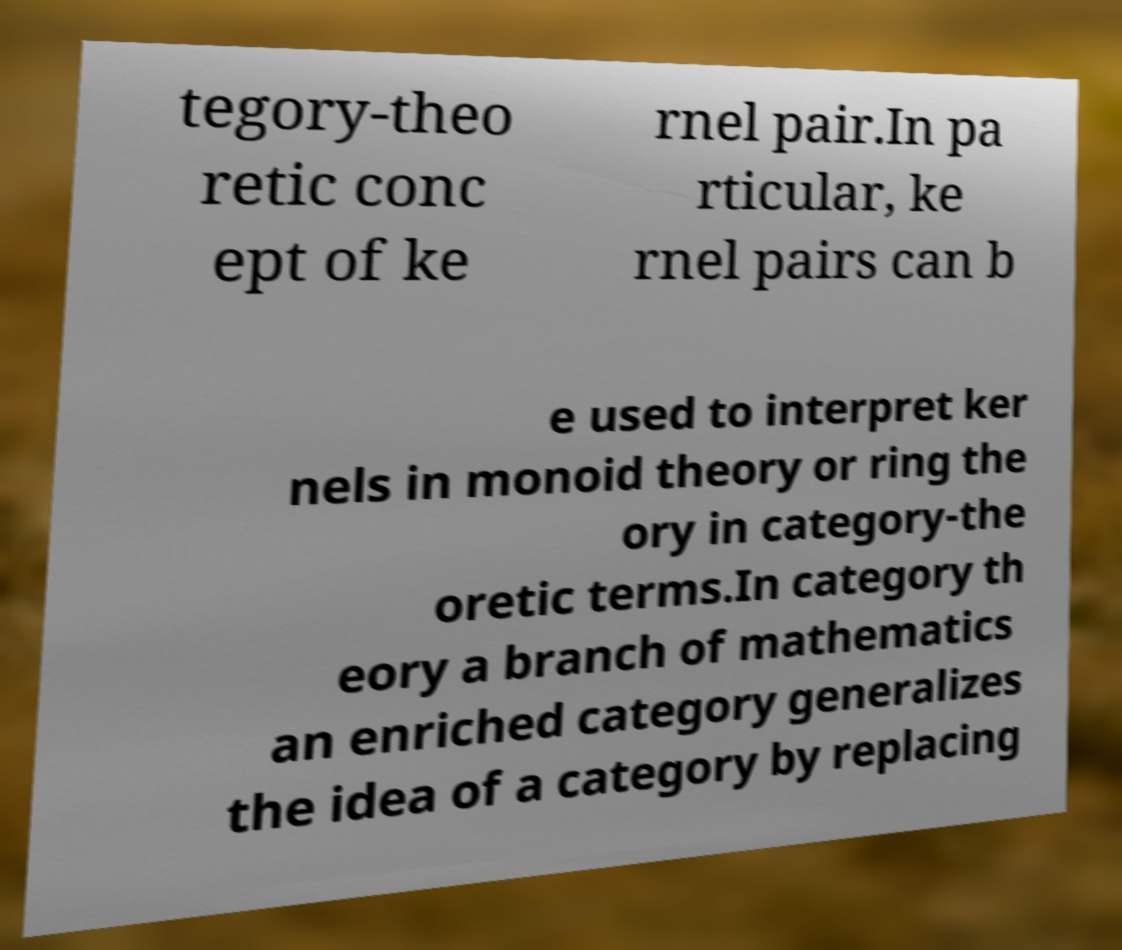Can you accurately transcribe the text from the provided image for me? tegory-theo retic conc ept of ke rnel pair.In pa rticular, ke rnel pairs can b e used to interpret ker nels in monoid theory or ring the ory in category-the oretic terms.In category th eory a branch of mathematics an enriched category generalizes the idea of a category by replacing 